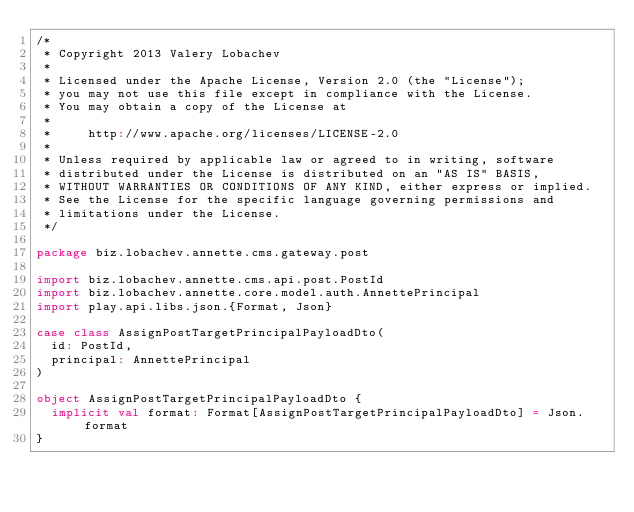Convert code to text. <code><loc_0><loc_0><loc_500><loc_500><_Scala_>/*
 * Copyright 2013 Valery Lobachev
 *
 * Licensed under the Apache License, Version 2.0 (the "License");
 * you may not use this file except in compliance with the License.
 * You may obtain a copy of the License at
 *
 *     http://www.apache.org/licenses/LICENSE-2.0
 *
 * Unless required by applicable law or agreed to in writing, software
 * distributed under the License is distributed on an "AS IS" BASIS,
 * WITHOUT WARRANTIES OR CONDITIONS OF ANY KIND, either express or implied.
 * See the License for the specific language governing permissions and
 * limitations under the License.
 */

package biz.lobachev.annette.cms.gateway.post

import biz.lobachev.annette.cms.api.post.PostId
import biz.lobachev.annette.core.model.auth.AnnettePrincipal
import play.api.libs.json.{Format, Json}

case class AssignPostTargetPrincipalPayloadDto(
  id: PostId,
  principal: AnnettePrincipal
)

object AssignPostTargetPrincipalPayloadDto {
  implicit val format: Format[AssignPostTargetPrincipalPayloadDto] = Json.format
}
</code> 